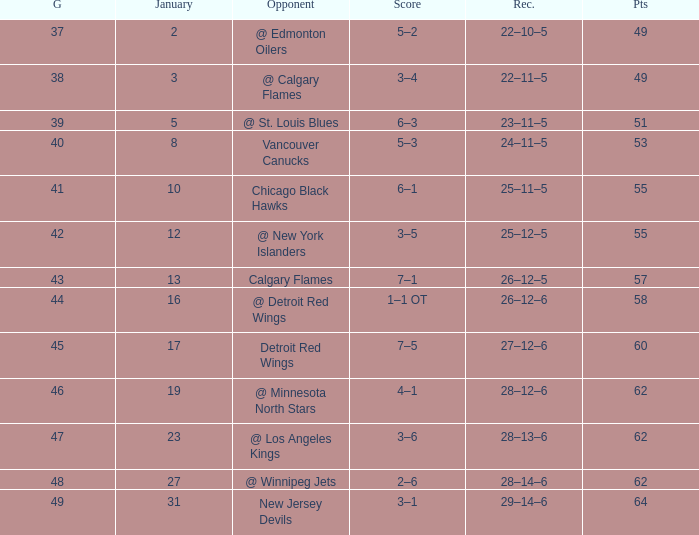How much January has a Record of 26–12–6, and Points smaller than 58? None. 